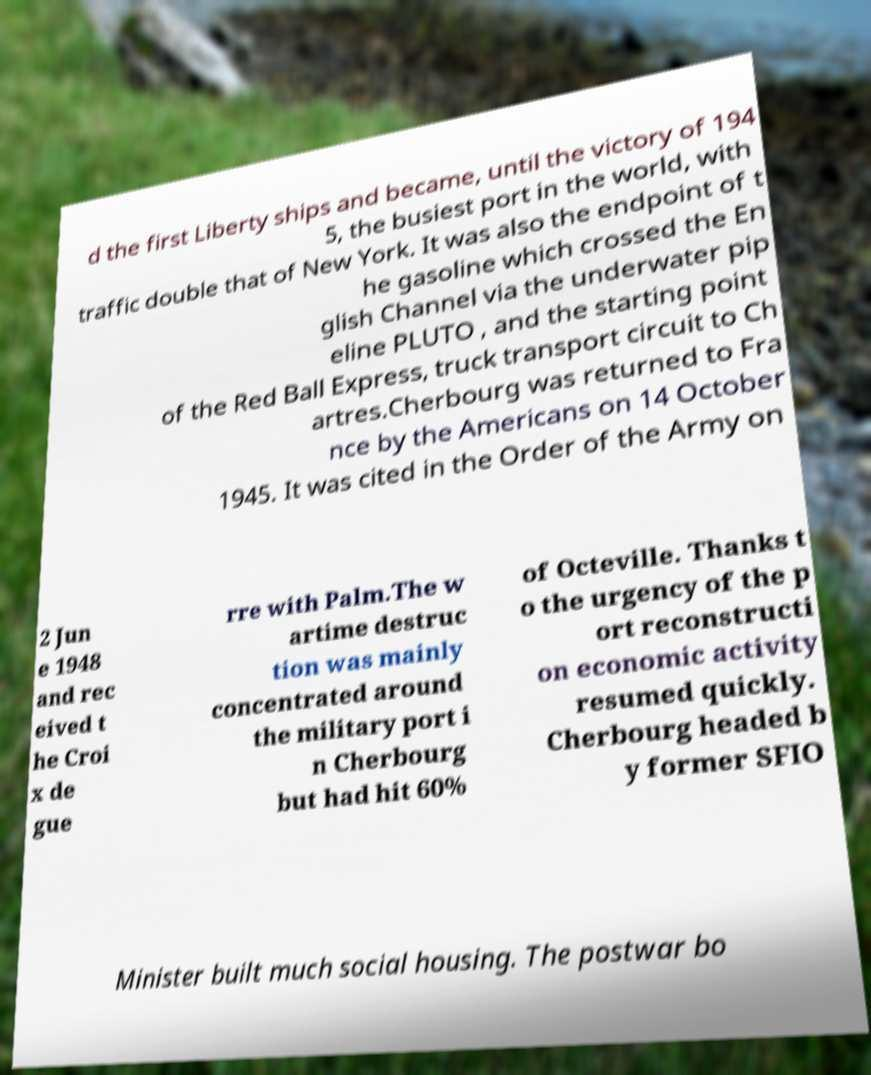I need the written content from this picture converted into text. Can you do that? d the first Liberty ships and became, until the victory of 194 5, the busiest port in the world, with traffic double that of New York. It was also the endpoint of t he gasoline which crossed the En glish Channel via the underwater pip eline PLUTO , and the starting point of the Red Ball Express, truck transport circuit to Ch artres.Cherbourg was returned to Fra nce by the Americans on 14 October 1945. It was cited in the Order of the Army on 2 Jun e 1948 and rec eived t he Croi x de gue rre with Palm.The w artime destruc tion was mainly concentrated around the military port i n Cherbourg but had hit 60% of Octeville. Thanks t o the urgency of the p ort reconstructi on economic activity resumed quickly. Cherbourg headed b y former SFIO Minister built much social housing. The postwar bo 